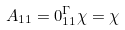Convert formula to latex. <formula><loc_0><loc_0><loc_500><loc_500>A _ { 1 1 } = 0 ^ { \Gamma } _ { 1 1 } \chi = \chi</formula> 